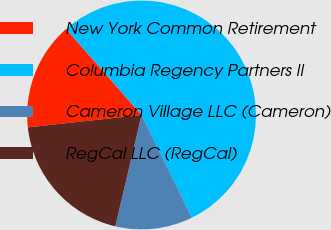Convert chart to OTSL. <chart><loc_0><loc_0><loc_500><loc_500><pie_chart><fcel>New York Common Retirement<fcel>Columbia Regency Partners II<fcel>Cameron Village LLC (Cameron)<fcel>RegCal LLC (RegCal)<nl><fcel>15.27%<fcel>54.2%<fcel>10.94%<fcel>19.59%<nl></chart> 